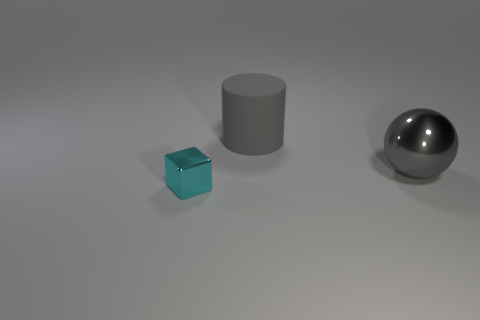Could you describe the surface the objects are resting on? The objects are resting on a flat, matte surface that has a subtle gradient, likely indicating a slight curvature or a gentle lighting effect that gives the scene a calm and balanced atmosphere. 